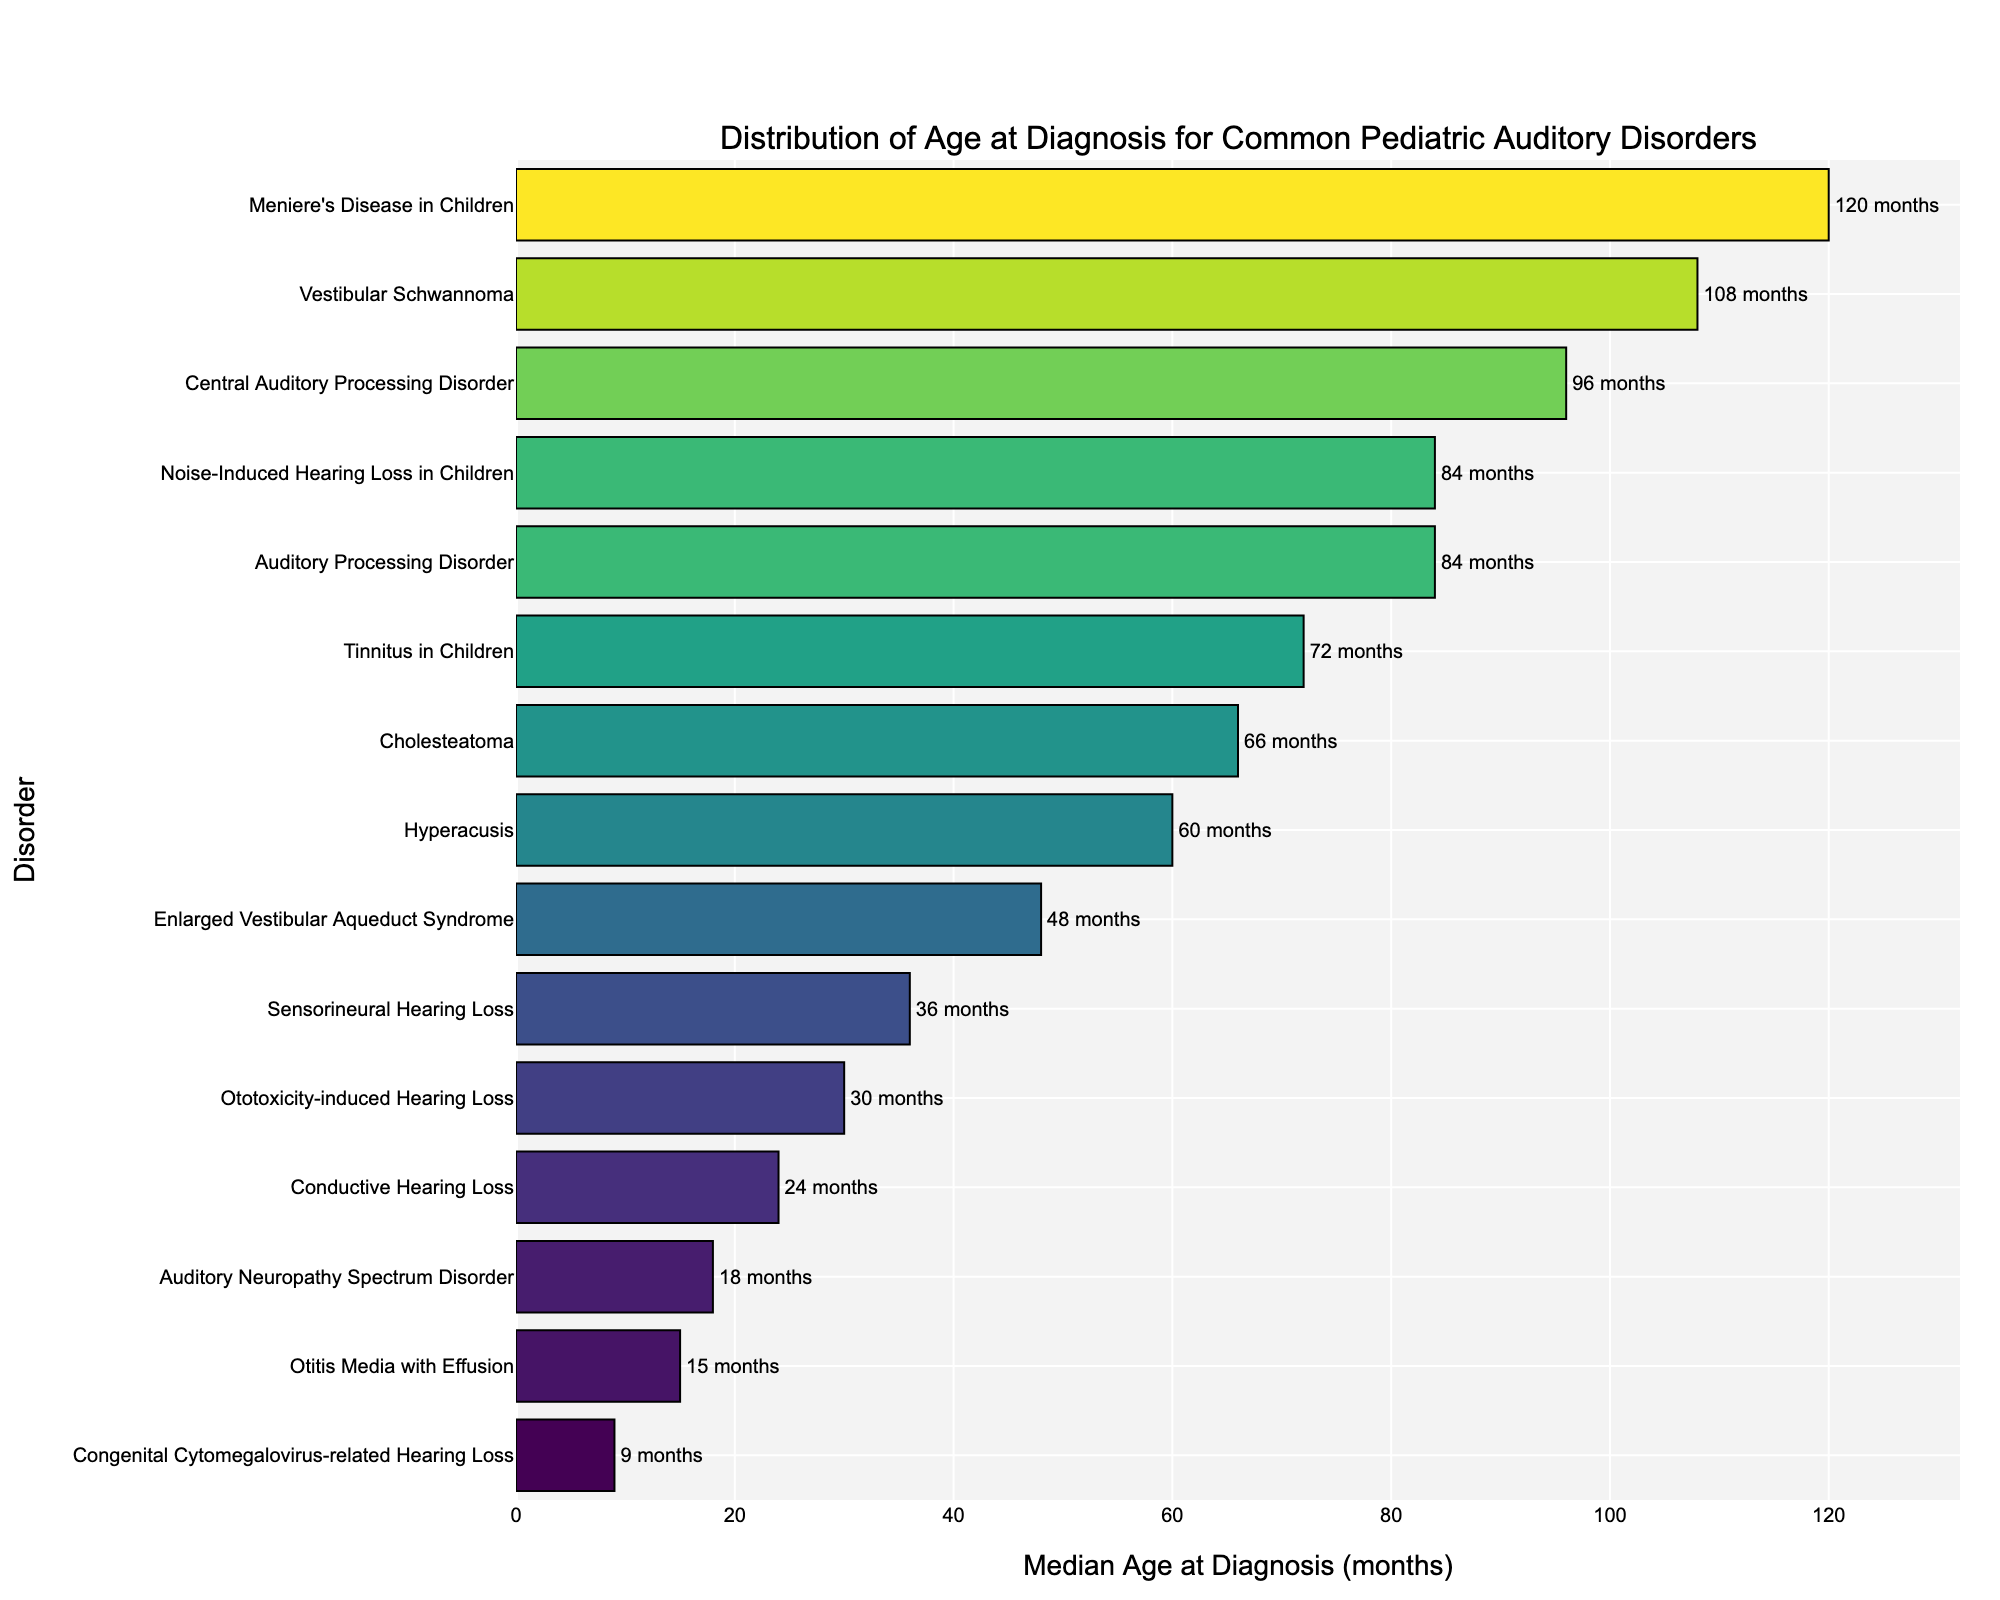What's the disorder with the earliest median age at diagnosis? Look for the shortest bar on the plot that represents the median age at diagnosis. The shortest bar corresponds to Congenital Cytomegalovirus-related Hearing Loss with a median age at diagnosis of 9 months.
Answer: Congenital Cytomegalovirus-related Hearing Loss Which disorder has the latest median age at diagnosis, and what is the age? Identify the longest bar on the plot, which indicates the latest median age at diagnosis. This bar corresponds to Meniere's Disease in Children, with a median age at diagnosis of 120 months.
Answer: Meniere's Disease in Children, 120 months Compare the median age at diagnosis for Tinnitus in Children and Hyperacusis. Which one is diagnosed later? Find the bars for Tinnitus in Children and Hyperacusis. The median age for Tinnitus in Children is 72 months, and for Hyperacusis, it is 60 months. Tinnitus in Children is diagnosed later.
Answer: Tinnitus in Children What is the median age difference between Auditory Neuropathy Spectrum Disorder and Otitis Media with Effusion? Locate the bars for both disorders. The median age at diagnosis for Auditory Neuropathy Spectrum Disorder is 18 months, and for Otitis Media with Effusion, it is 15 months. The difference is 3 months.
Answer: 3 months Which disorders are diagnosed between 80 and 100 months of age? Find the bars that fall within the 80-100 months range on the x-axis. These bars correspond to Auditory Processing Disorder, Noise-Induced Hearing Loss in Children, and Central Auditory Processing Disorder.
Answer: Auditory Processing Disorder, Noise-Induced Hearing Loss in Children, Central Auditory Processing Disorder How does the median age at diagnosis for Cholesteatoma compare to that of Ototoxicity-induced Hearing Loss? Look at the bars for Cholesteatoma and Ototoxicity-induced Hearing Loss. The median age for Cholesteatoma is 66 months, and for Ototoxicity-induced Hearing Loss, it is 30 months. Cholesteatoma is diagnosed later.
Answer: Cholesteatoma Calculate the average median age at diagnosis for the disorders diagnosed before 24 months. The disorders diagnosed before 24 months are Otitis Media with Effusion (15 months), Auditory Neuropathy Spectrum Disorder (18 months), and Congenital Cytomegalovirus-related Hearing Loss (9 months). The average is (15+18+9)/3 = 14 months.
Answer: 14 months Which disorder has a median age at diagnosis closest to 36 months? Identify the bar whose length is closest to 36 months on the x-axis. This bar corresponds to Sensorineural Hearing Loss.
Answer: Sensorineural Hearing Loss What is the range of median ages at diagnosis for the listed disorders? Evaluate the shortest and longest bars in terms of length. The shortest bar is for Congenital Cytomegalovirus-related Hearing Loss (9 months), and the longest bar is for Meniere's Disease in Children (120 months). The range is 120 - 9 = 111 months.
Answer: 111 months Are more disorders diagnosed before or after the median age of 50 months? Count the number of bars to the left and right of the 50-month mark on the x-axis. There are more disorders diagnosed after 50 months.
Answer: After 